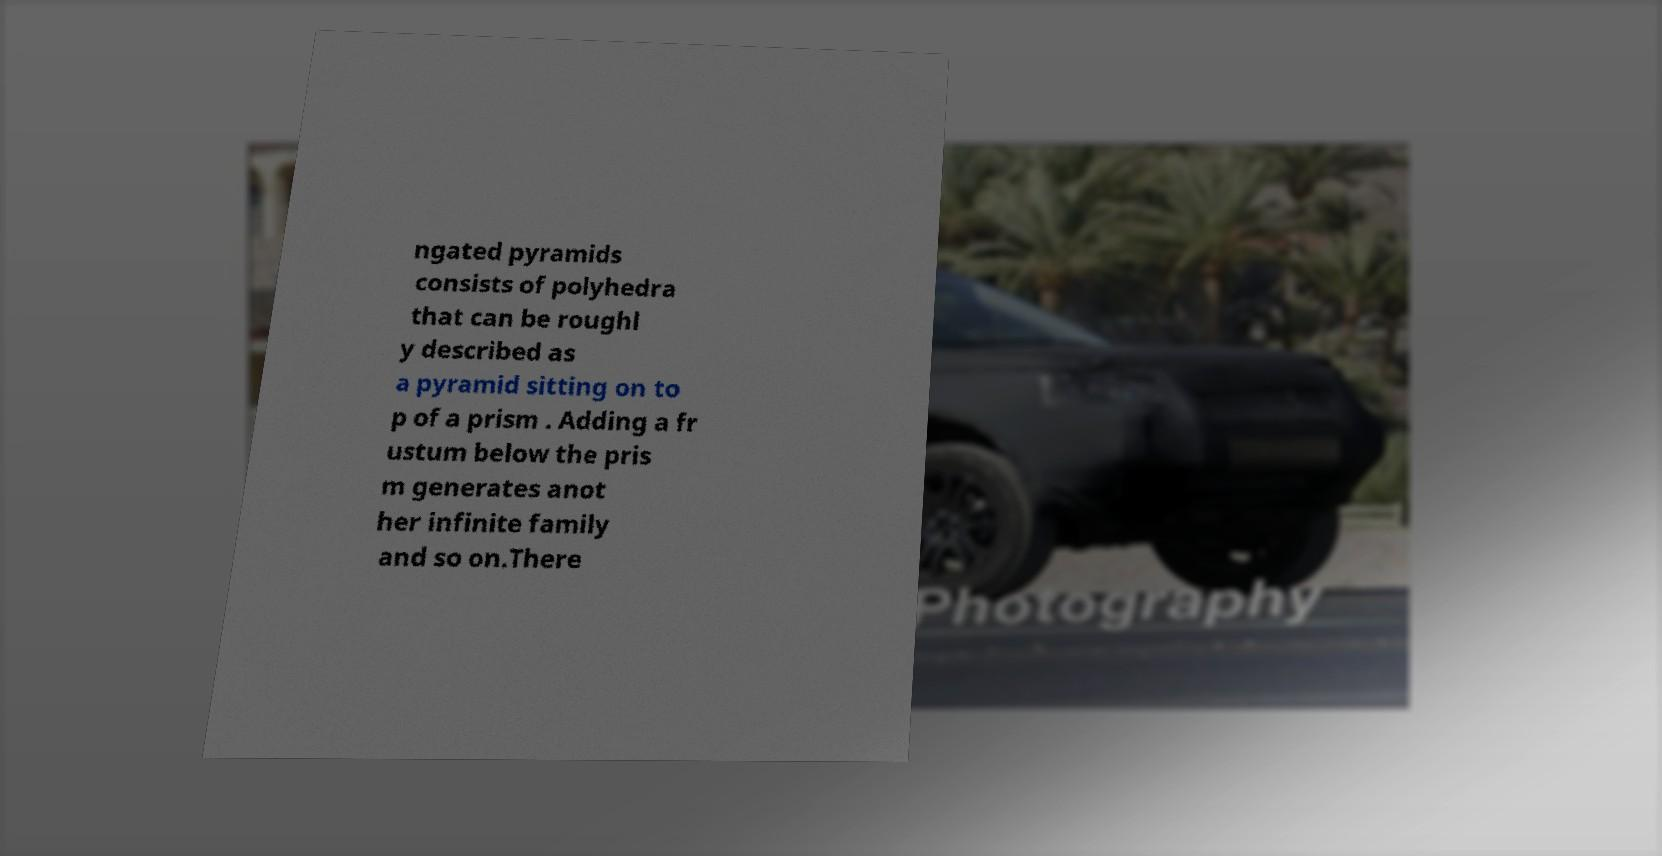For documentation purposes, I need the text within this image transcribed. Could you provide that? ngated pyramids consists of polyhedra that can be roughl y described as a pyramid sitting on to p of a prism . Adding a fr ustum below the pris m generates anot her infinite family and so on.There 